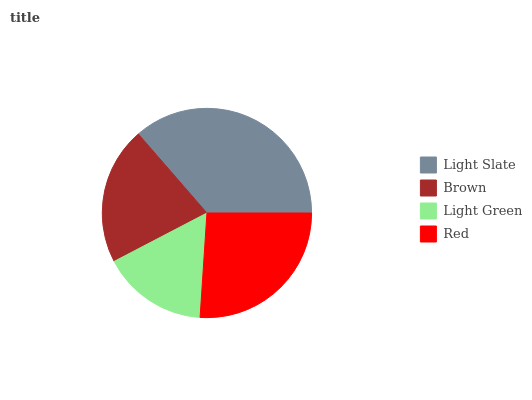Is Light Green the minimum?
Answer yes or no. Yes. Is Light Slate the maximum?
Answer yes or no. Yes. Is Brown the minimum?
Answer yes or no. No. Is Brown the maximum?
Answer yes or no. No. Is Light Slate greater than Brown?
Answer yes or no. Yes. Is Brown less than Light Slate?
Answer yes or no. Yes. Is Brown greater than Light Slate?
Answer yes or no. No. Is Light Slate less than Brown?
Answer yes or no. No. Is Red the high median?
Answer yes or no. Yes. Is Brown the low median?
Answer yes or no. Yes. Is Light Slate the high median?
Answer yes or no. No. Is Light Slate the low median?
Answer yes or no. No. 